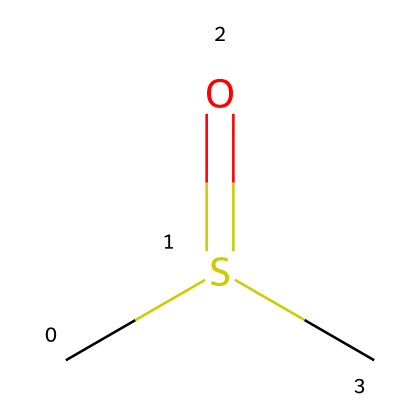How many carbon atoms are present in dimethyl sulfoxide (DMSO)? The SMILES representation shows "CS(=O)C", where "C" indicates carbon atoms. In this case, there are 2 "C" present, representing two carbon atoms in the chemical structure.
Answer: 2 What functional group is present in dimethyl sulfoxide? The presence of the "S(=O)" in the SMILES indicates the presence of a sulfoxide functional group, identified by the sulfur atom bonded to oxygen with a double bond, defining the functional characteristics.
Answer: sulfoxide What is the total number of atoms in dimethyl sulfoxide (DMSO)? Analyzing the SMILES "CS(=O)C", we count 2 carbon (C), 1 sulfur (S), and 1 oxygen (O) atom, giving a total of 4 atoms.
Answer: 4 Which element is the central atom in dimethyl sulfoxide? In the provided structure, the central atom is the sulfur atom "S," as it is bonded to both oxygen and the two carbon groups, indicating its central role in the molecule's composition.
Answer: sulfur What type of bond connects the sulfur and oxygen in dimethyl sulfoxide? The SMILES shows "S(=O)", where the "=" signifies a double bond between sulfur and oxygen, which is characteristic of sulfoxides.
Answer: double bond What type of compound is dimethyl sulfoxide categorized as? Given the presence of both carbon and sulfur alongside the sulfoxide functional group, dimethyl sulfoxide is categorized as an organosulfur compound, indicating its classification within organic compounds containing sulfur.
Answer: organosulfur compound 